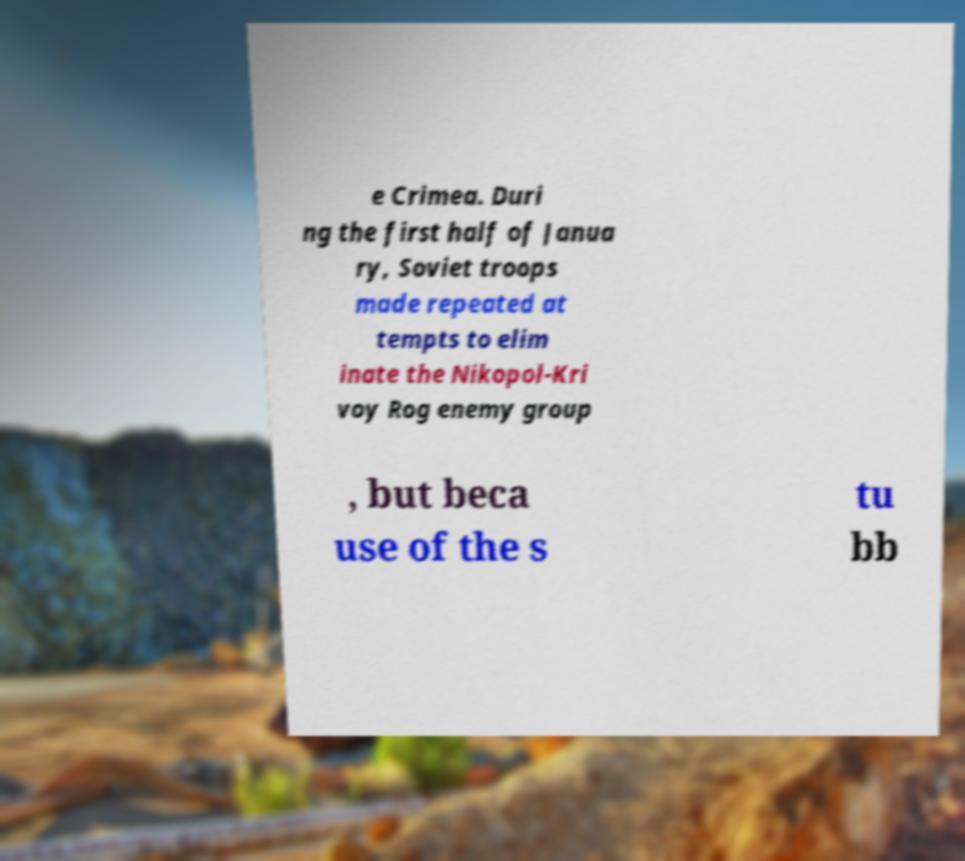For documentation purposes, I need the text within this image transcribed. Could you provide that? e Crimea. Duri ng the first half of Janua ry, Soviet troops made repeated at tempts to elim inate the Nikopol-Kri voy Rog enemy group , but beca use of the s tu bb 